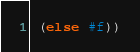Convert code to text. <code><loc_0><loc_0><loc_500><loc_500><_Scheme_> (else #f))
</code> 